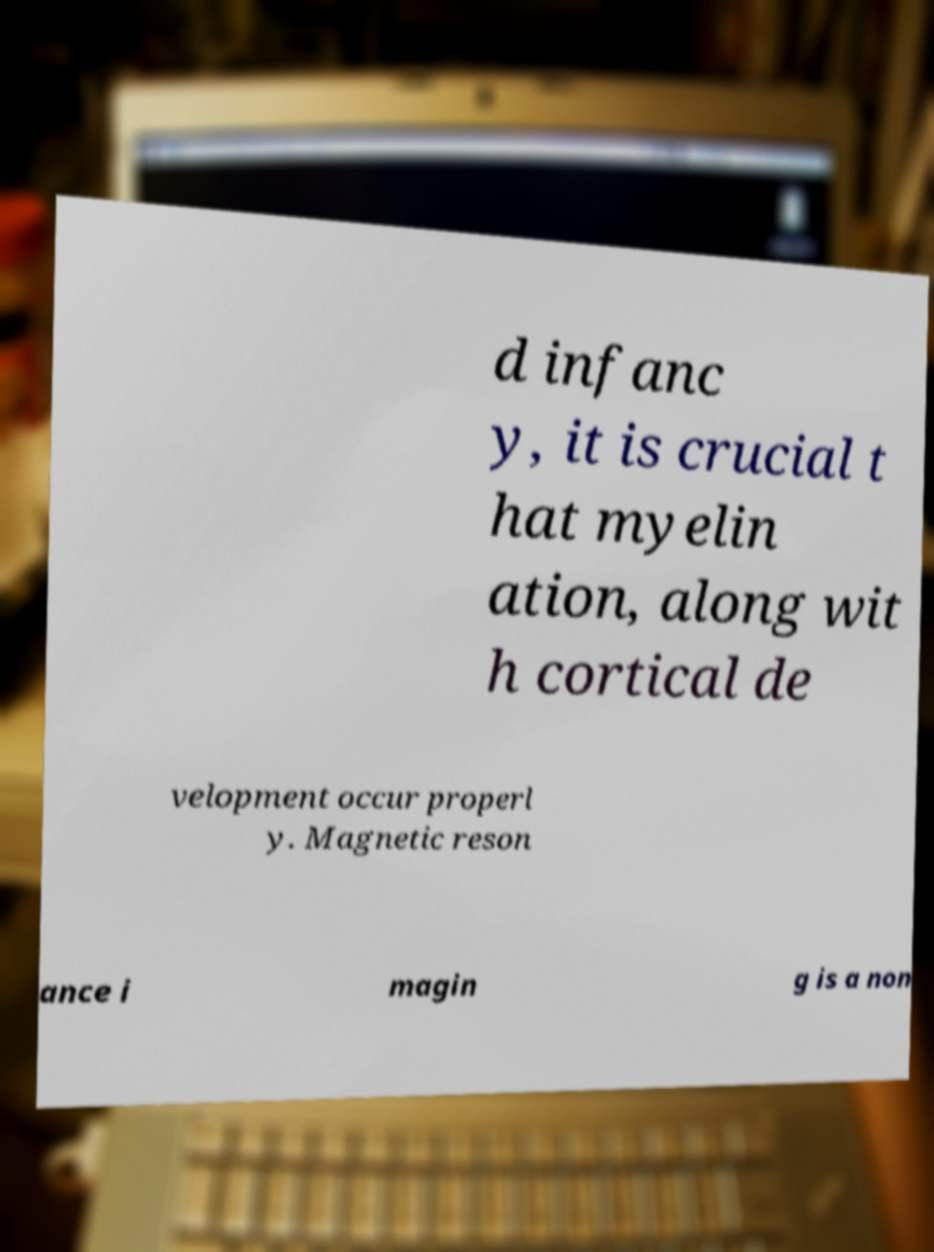Can you read and provide the text displayed in the image?This photo seems to have some interesting text. Can you extract and type it out for me? d infanc y, it is crucial t hat myelin ation, along wit h cortical de velopment occur properl y. Magnetic reson ance i magin g is a non 